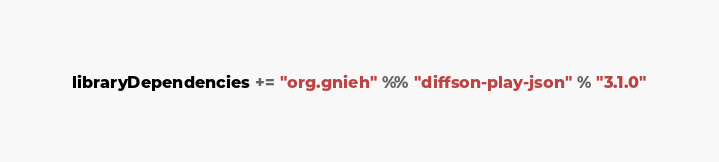<code> <loc_0><loc_0><loc_500><loc_500><_Scala_>
libraryDependencies += "org.gnieh" %% "diffson-play-json" % "3.1.0"
</code> 